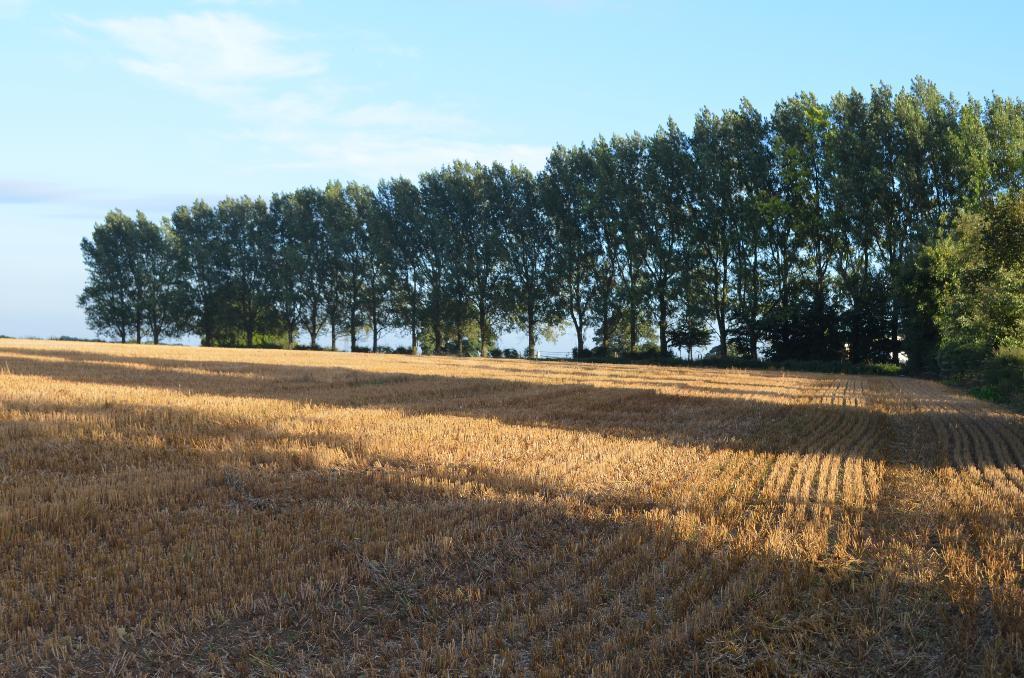Describe this image in one or two sentences. This picture is clicked outside the city. In the foreground we can see the items seems to be the crops. In the background there is a sky, plants and trees. 